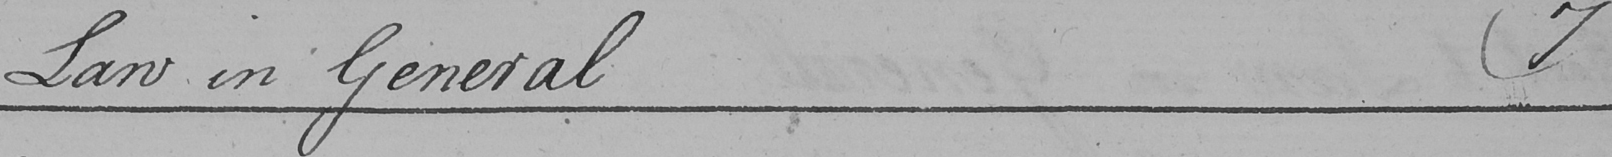Please transcribe the handwritten text in this image. Law in General  ( 7 